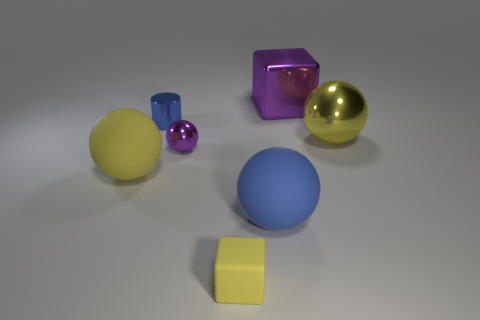What number of other things are the same color as the big block?
Provide a succinct answer. 1. There is a thing that is both to the left of the tiny rubber object and right of the metal cylinder; what color is it?
Provide a short and direct response. Purple. What number of small matte objects are there?
Provide a succinct answer. 1. Is the material of the small yellow object the same as the purple cube?
Provide a succinct answer. No. The blue thing in front of the big ball left of the small yellow matte cube that is on the left side of the big block is what shape?
Provide a short and direct response. Sphere. Is the purple object in front of the small blue metal thing made of the same material as the large yellow thing to the right of the tiny yellow block?
Provide a succinct answer. Yes. What material is the blue cylinder?
Provide a short and direct response. Metal. How many big yellow rubber objects have the same shape as the small purple metal object?
Keep it short and to the point. 1. There is a thing that is the same color as the cylinder; what material is it?
Provide a succinct answer. Rubber. Is there anything else that is the same shape as the small yellow rubber object?
Make the answer very short. Yes. 